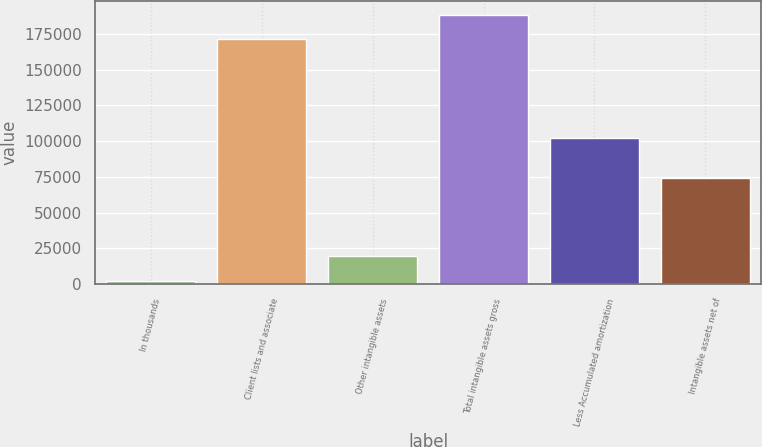Convert chart. <chart><loc_0><loc_0><loc_500><loc_500><bar_chart><fcel>In thousands<fcel>Client lists and associate<fcel>Other intangible assets<fcel>Total intangible assets gross<fcel>Less Accumulated amortization<fcel>Intangible assets net of<nl><fcel>2008<fcel>170984<fcel>19473.1<fcel>188449<fcel>102159<fcel>74500<nl></chart> 